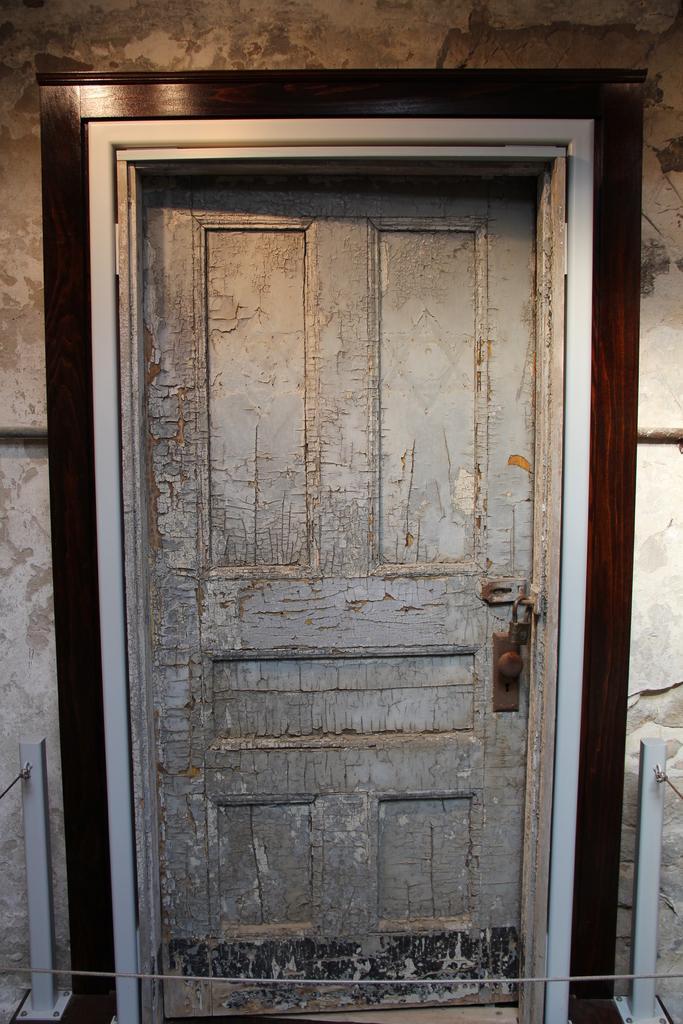How would you summarize this image in a sentence or two? In this image we can see a wooden door with lock. 